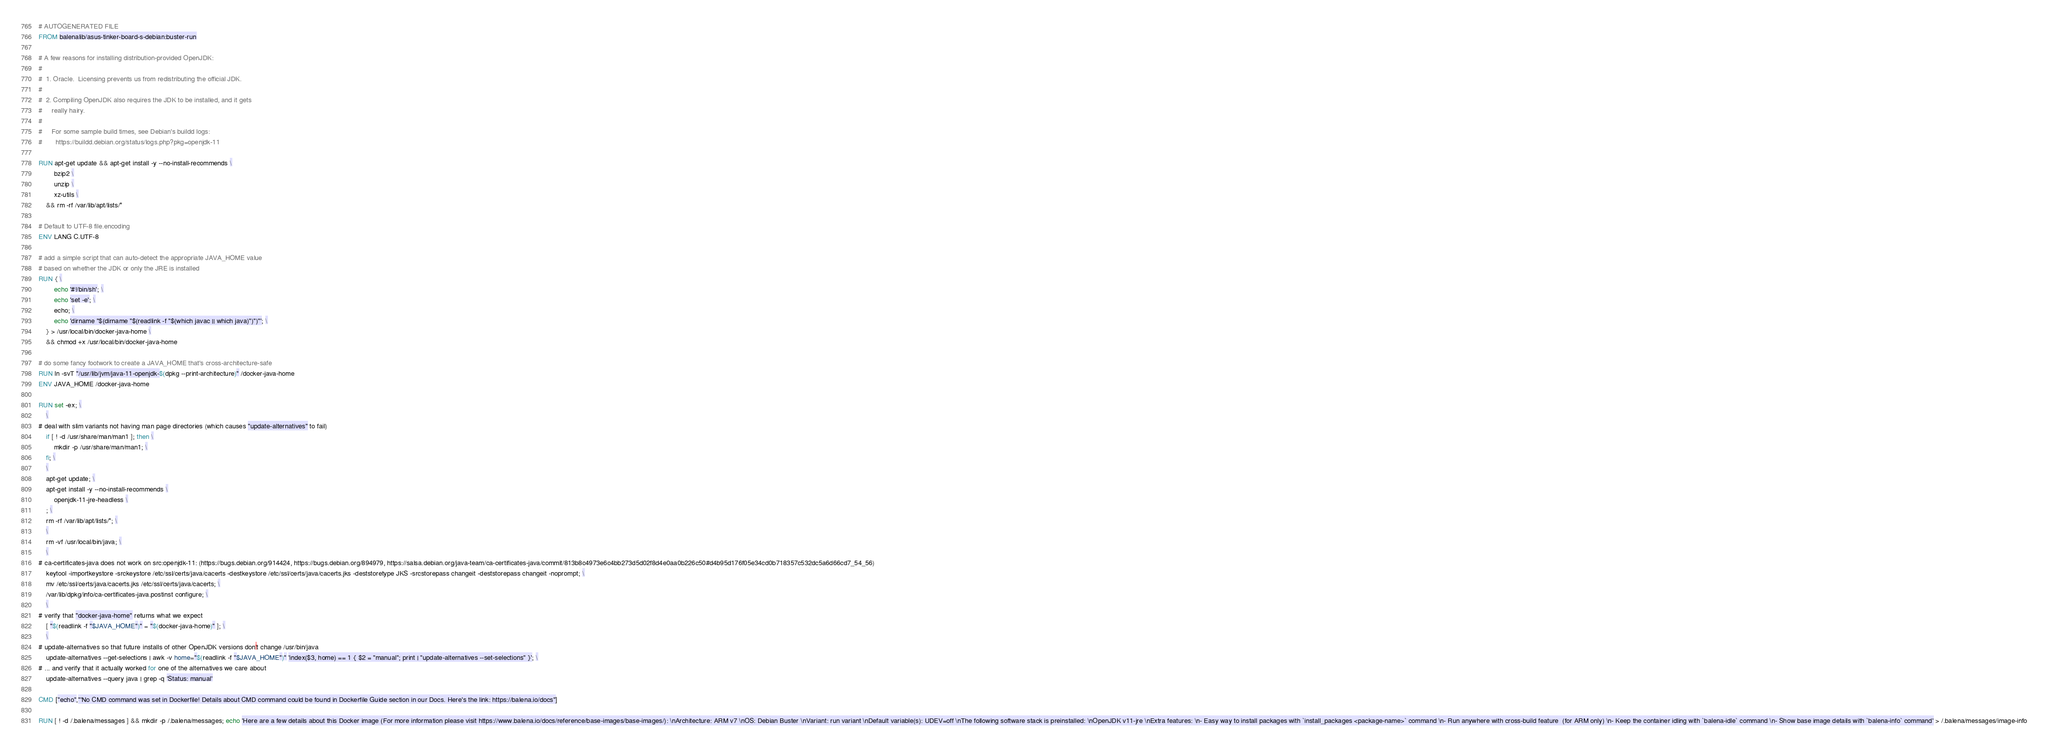Convert code to text. <code><loc_0><loc_0><loc_500><loc_500><_Dockerfile_># AUTOGENERATED FILE
FROM balenalib/asus-tinker-board-s-debian:buster-run

# A few reasons for installing distribution-provided OpenJDK:
#
#  1. Oracle.  Licensing prevents us from redistributing the official JDK.
#
#  2. Compiling OpenJDK also requires the JDK to be installed, and it gets
#     really hairy.
#
#     For some sample build times, see Debian's buildd logs:
#       https://buildd.debian.org/status/logs.php?pkg=openjdk-11

RUN apt-get update && apt-get install -y --no-install-recommends \
		bzip2 \
		unzip \
		xz-utils \
	&& rm -rf /var/lib/apt/lists/*

# Default to UTF-8 file.encoding
ENV LANG C.UTF-8

# add a simple script that can auto-detect the appropriate JAVA_HOME value
# based on whether the JDK or only the JRE is installed
RUN { \
		echo '#!/bin/sh'; \
		echo 'set -e'; \
		echo; \
		echo 'dirname "$(dirname "$(readlink -f "$(which javac || which java)")")"'; \
	} > /usr/local/bin/docker-java-home \
	&& chmod +x /usr/local/bin/docker-java-home

# do some fancy footwork to create a JAVA_HOME that's cross-architecture-safe
RUN ln -svT "/usr/lib/jvm/java-11-openjdk-$(dpkg --print-architecture)" /docker-java-home
ENV JAVA_HOME /docker-java-home

RUN set -ex; \
	\
# deal with slim variants not having man page directories (which causes "update-alternatives" to fail)
	if [ ! -d /usr/share/man/man1 ]; then \
		mkdir -p /usr/share/man/man1; \
	fi; \
	\
	apt-get update; \
	apt-get install -y --no-install-recommends \
		openjdk-11-jre-headless \
	; \
	rm -rf /var/lib/apt/lists/*; \
	\
	rm -vf /usr/local/bin/java; \
	\
# ca-certificates-java does not work on src:openjdk-11: (https://bugs.debian.org/914424, https://bugs.debian.org/894979, https://salsa.debian.org/java-team/ca-certificates-java/commit/813b8c4973e6c4bb273d5d02f8d4e0aa0b226c50#d4b95d176f05e34cd0b718357c532dc5a6d66cd7_54_56)
	keytool -importkeystore -srckeystore /etc/ssl/certs/java/cacerts -destkeystore /etc/ssl/certs/java/cacerts.jks -deststoretype JKS -srcstorepass changeit -deststorepass changeit -noprompt; \
	mv /etc/ssl/certs/java/cacerts.jks /etc/ssl/certs/java/cacerts; \
	/var/lib/dpkg/info/ca-certificates-java.postinst configure; \
	\
# verify that "docker-java-home" returns what we expect
	[ "$(readlink -f "$JAVA_HOME")" = "$(docker-java-home)" ]; \
	\
# update-alternatives so that future installs of other OpenJDK versions don't change /usr/bin/java
	update-alternatives --get-selections | awk -v home="$(readlink -f "$JAVA_HOME")" 'index($3, home) == 1 { $2 = "manual"; print | "update-alternatives --set-selections" }'; \
# ... and verify that it actually worked for one of the alternatives we care about
	update-alternatives --query java | grep -q 'Status: manual'

CMD ["echo","'No CMD command was set in Dockerfile! Details about CMD command could be found in Dockerfile Guide section in our Docs. Here's the link: https://balena.io/docs"]

RUN [ ! -d /.balena/messages ] && mkdir -p /.balena/messages; echo 'Here are a few details about this Docker image (For more information please visit https://www.balena.io/docs/reference/base-images/base-images/): \nArchitecture: ARM v7 \nOS: Debian Buster \nVariant: run variant \nDefault variable(s): UDEV=off \nThe following software stack is preinstalled: \nOpenJDK v11-jre \nExtra features: \n- Easy way to install packages with `install_packages <package-name>` command \n- Run anywhere with cross-build feature  (for ARM only) \n- Keep the container idling with `balena-idle` command \n- Show base image details with `balena-info` command' > /.balena/messages/image-info</code> 